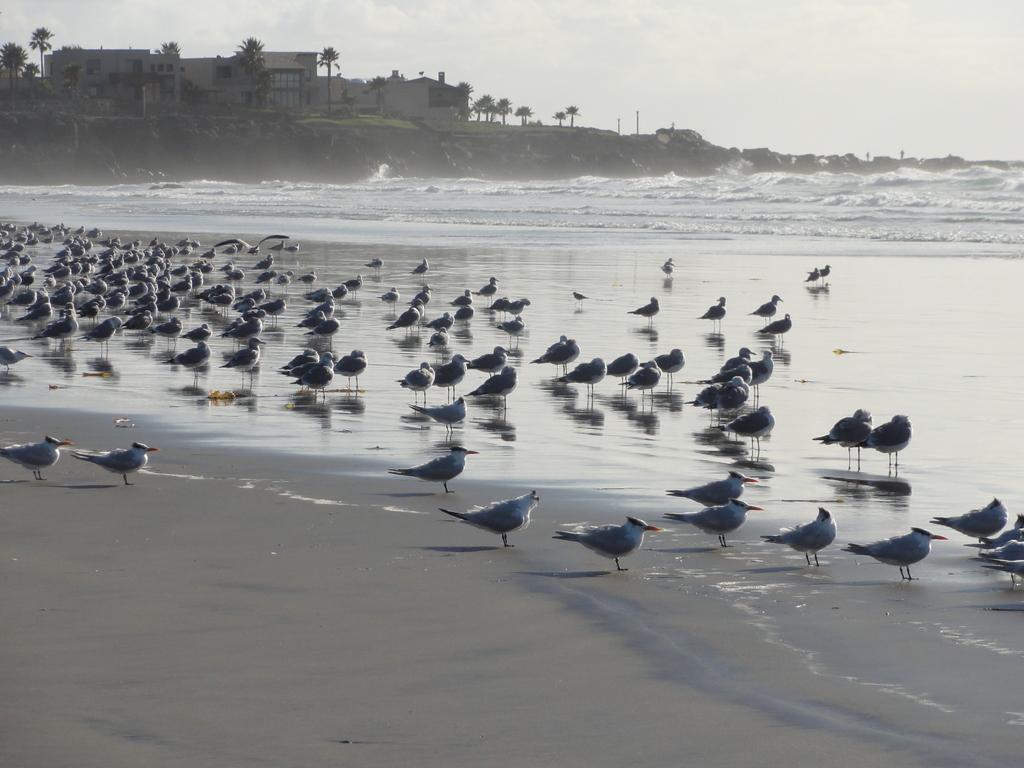Could you give a brief overview of what you see in this image? In this picture we can observe some birds standing in the beach. We can observe an ocean here. In the background there are trees and a building. We can observe a sky here. 